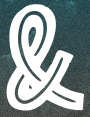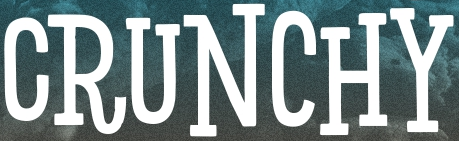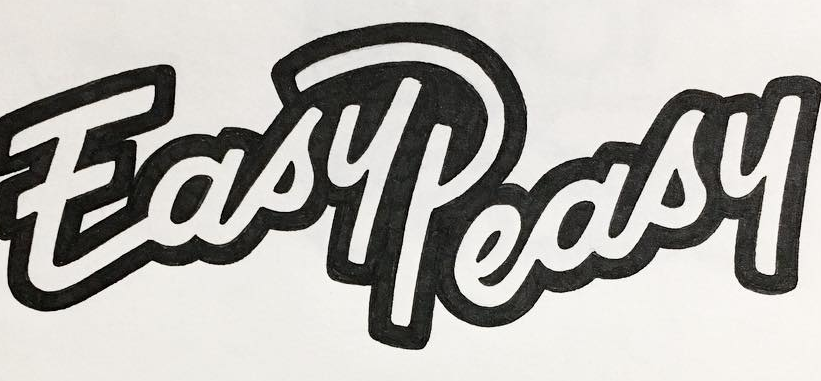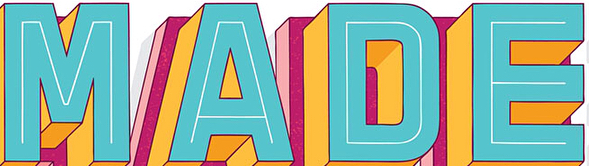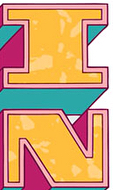What text is displayed in these images sequentially, separated by a semicolon? &; CRUNCHY; EasyPeasy; MADE; IN 